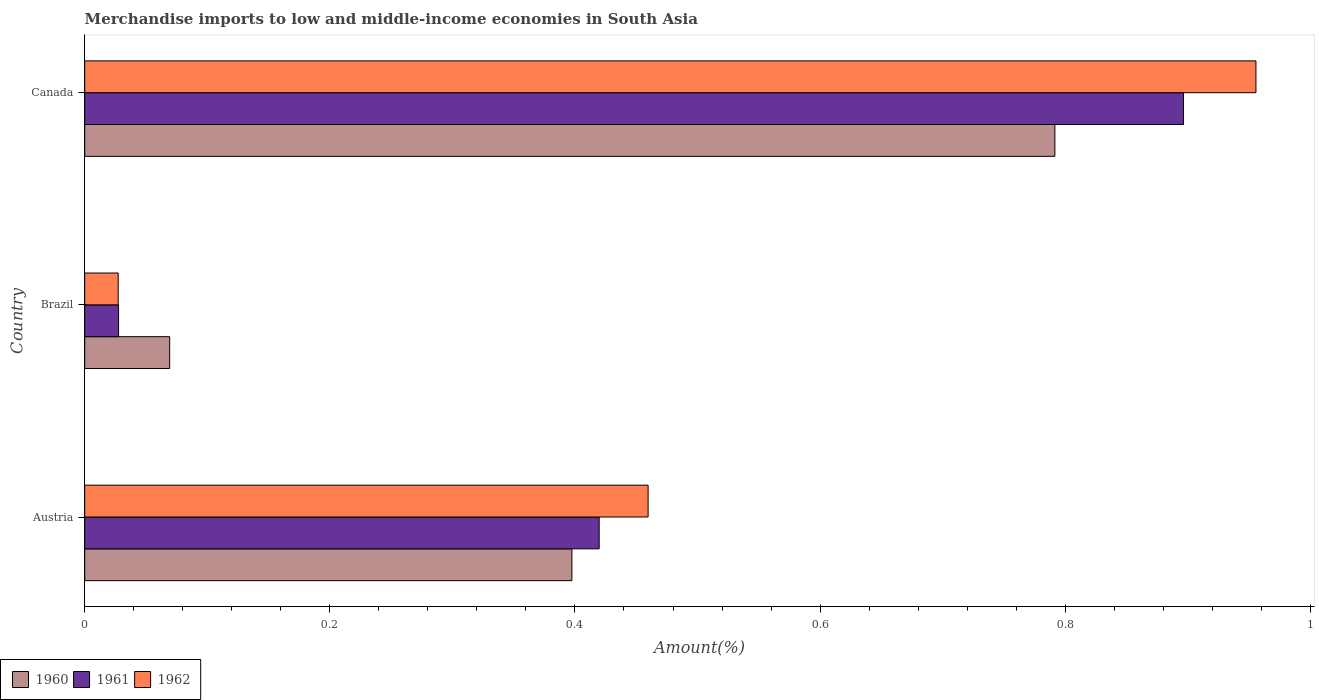How many groups of bars are there?
Give a very brief answer. 3. Are the number of bars on each tick of the Y-axis equal?
Give a very brief answer. Yes. How many bars are there on the 3rd tick from the top?
Your response must be concise. 3. What is the label of the 1st group of bars from the top?
Provide a succinct answer. Canada. What is the percentage of amount earned from merchandise imports in 1961 in Canada?
Your answer should be very brief. 0.9. Across all countries, what is the maximum percentage of amount earned from merchandise imports in 1961?
Make the answer very short. 0.9. Across all countries, what is the minimum percentage of amount earned from merchandise imports in 1962?
Make the answer very short. 0.03. In which country was the percentage of amount earned from merchandise imports in 1960 minimum?
Make the answer very short. Brazil. What is the total percentage of amount earned from merchandise imports in 1961 in the graph?
Your answer should be compact. 1.34. What is the difference between the percentage of amount earned from merchandise imports in 1962 in Austria and that in Brazil?
Your response must be concise. 0.43. What is the difference between the percentage of amount earned from merchandise imports in 1960 in Canada and the percentage of amount earned from merchandise imports in 1962 in Brazil?
Your answer should be compact. 0.76. What is the average percentage of amount earned from merchandise imports in 1962 per country?
Offer a terse response. 0.48. What is the difference between the percentage of amount earned from merchandise imports in 1960 and percentage of amount earned from merchandise imports in 1962 in Canada?
Your answer should be very brief. -0.16. In how many countries, is the percentage of amount earned from merchandise imports in 1960 greater than 0.32 %?
Give a very brief answer. 2. What is the ratio of the percentage of amount earned from merchandise imports in 1960 in Brazil to that in Canada?
Your answer should be very brief. 0.09. Is the percentage of amount earned from merchandise imports in 1961 in Austria less than that in Canada?
Provide a short and direct response. Yes. What is the difference between the highest and the second highest percentage of amount earned from merchandise imports in 1960?
Your answer should be very brief. 0.39. What is the difference between the highest and the lowest percentage of amount earned from merchandise imports in 1960?
Provide a succinct answer. 0.72. What does the 1st bar from the bottom in Brazil represents?
Provide a succinct answer. 1960. What is the difference between two consecutive major ticks on the X-axis?
Give a very brief answer. 0.2. Does the graph contain grids?
Keep it short and to the point. No. Where does the legend appear in the graph?
Provide a short and direct response. Bottom left. How many legend labels are there?
Provide a succinct answer. 3. How are the legend labels stacked?
Ensure brevity in your answer.  Horizontal. What is the title of the graph?
Keep it short and to the point. Merchandise imports to low and middle-income economies in South Asia. What is the label or title of the X-axis?
Your answer should be very brief. Amount(%). What is the Amount(%) in 1960 in Austria?
Your answer should be very brief. 0.4. What is the Amount(%) of 1961 in Austria?
Provide a short and direct response. 0.42. What is the Amount(%) in 1962 in Austria?
Offer a very short reply. 0.46. What is the Amount(%) in 1960 in Brazil?
Offer a very short reply. 0.07. What is the Amount(%) in 1961 in Brazil?
Provide a succinct answer. 0.03. What is the Amount(%) in 1962 in Brazil?
Offer a very short reply. 0.03. What is the Amount(%) of 1960 in Canada?
Keep it short and to the point. 0.79. What is the Amount(%) in 1961 in Canada?
Keep it short and to the point. 0.9. What is the Amount(%) in 1962 in Canada?
Your response must be concise. 0.96. Across all countries, what is the maximum Amount(%) of 1960?
Your answer should be very brief. 0.79. Across all countries, what is the maximum Amount(%) of 1961?
Provide a short and direct response. 0.9. Across all countries, what is the maximum Amount(%) in 1962?
Provide a succinct answer. 0.96. Across all countries, what is the minimum Amount(%) in 1960?
Your answer should be compact. 0.07. Across all countries, what is the minimum Amount(%) in 1961?
Provide a short and direct response. 0.03. Across all countries, what is the minimum Amount(%) in 1962?
Offer a terse response. 0.03. What is the total Amount(%) of 1960 in the graph?
Offer a very short reply. 1.26. What is the total Amount(%) in 1961 in the graph?
Your answer should be very brief. 1.34. What is the total Amount(%) of 1962 in the graph?
Your answer should be very brief. 1.44. What is the difference between the Amount(%) in 1960 in Austria and that in Brazil?
Give a very brief answer. 0.33. What is the difference between the Amount(%) of 1961 in Austria and that in Brazil?
Provide a succinct answer. 0.39. What is the difference between the Amount(%) in 1962 in Austria and that in Brazil?
Offer a very short reply. 0.43. What is the difference between the Amount(%) of 1960 in Austria and that in Canada?
Provide a short and direct response. -0.39. What is the difference between the Amount(%) in 1961 in Austria and that in Canada?
Provide a short and direct response. -0.48. What is the difference between the Amount(%) in 1962 in Austria and that in Canada?
Keep it short and to the point. -0.5. What is the difference between the Amount(%) in 1960 in Brazil and that in Canada?
Ensure brevity in your answer.  -0.72. What is the difference between the Amount(%) in 1961 in Brazil and that in Canada?
Provide a short and direct response. -0.87. What is the difference between the Amount(%) in 1962 in Brazil and that in Canada?
Your answer should be compact. -0.93. What is the difference between the Amount(%) of 1960 in Austria and the Amount(%) of 1961 in Brazil?
Provide a succinct answer. 0.37. What is the difference between the Amount(%) of 1960 in Austria and the Amount(%) of 1962 in Brazil?
Offer a terse response. 0.37. What is the difference between the Amount(%) in 1961 in Austria and the Amount(%) in 1962 in Brazil?
Give a very brief answer. 0.39. What is the difference between the Amount(%) in 1960 in Austria and the Amount(%) in 1961 in Canada?
Keep it short and to the point. -0.5. What is the difference between the Amount(%) of 1960 in Austria and the Amount(%) of 1962 in Canada?
Provide a short and direct response. -0.56. What is the difference between the Amount(%) of 1961 in Austria and the Amount(%) of 1962 in Canada?
Offer a very short reply. -0.54. What is the difference between the Amount(%) of 1960 in Brazil and the Amount(%) of 1961 in Canada?
Your answer should be very brief. -0.83. What is the difference between the Amount(%) of 1960 in Brazil and the Amount(%) of 1962 in Canada?
Keep it short and to the point. -0.89. What is the difference between the Amount(%) of 1961 in Brazil and the Amount(%) of 1962 in Canada?
Your answer should be very brief. -0.93. What is the average Amount(%) in 1960 per country?
Provide a succinct answer. 0.42. What is the average Amount(%) in 1961 per country?
Give a very brief answer. 0.45. What is the average Amount(%) in 1962 per country?
Provide a short and direct response. 0.48. What is the difference between the Amount(%) in 1960 and Amount(%) in 1961 in Austria?
Provide a short and direct response. -0.02. What is the difference between the Amount(%) of 1960 and Amount(%) of 1962 in Austria?
Your answer should be very brief. -0.06. What is the difference between the Amount(%) in 1961 and Amount(%) in 1962 in Austria?
Provide a short and direct response. -0.04. What is the difference between the Amount(%) in 1960 and Amount(%) in 1961 in Brazil?
Your answer should be very brief. 0.04. What is the difference between the Amount(%) in 1960 and Amount(%) in 1962 in Brazil?
Ensure brevity in your answer.  0.04. What is the difference between the Amount(%) of 1960 and Amount(%) of 1961 in Canada?
Offer a terse response. -0.1. What is the difference between the Amount(%) in 1960 and Amount(%) in 1962 in Canada?
Offer a very short reply. -0.16. What is the difference between the Amount(%) of 1961 and Amount(%) of 1962 in Canada?
Ensure brevity in your answer.  -0.06. What is the ratio of the Amount(%) in 1960 in Austria to that in Brazil?
Your answer should be compact. 5.73. What is the ratio of the Amount(%) in 1961 in Austria to that in Brazil?
Offer a very short reply. 15.2. What is the ratio of the Amount(%) of 1962 in Austria to that in Brazil?
Offer a terse response. 16.83. What is the ratio of the Amount(%) of 1960 in Austria to that in Canada?
Provide a short and direct response. 0.5. What is the ratio of the Amount(%) in 1961 in Austria to that in Canada?
Provide a short and direct response. 0.47. What is the ratio of the Amount(%) in 1962 in Austria to that in Canada?
Provide a short and direct response. 0.48. What is the ratio of the Amount(%) of 1960 in Brazil to that in Canada?
Ensure brevity in your answer.  0.09. What is the ratio of the Amount(%) in 1961 in Brazil to that in Canada?
Offer a terse response. 0.03. What is the ratio of the Amount(%) of 1962 in Brazil to that in Canada?
Make the answer very short. 0.03. What is the difference between the highest and the second highest Amount(%) of 1960?
Offer a terse response. 0.39. What is the difference between the highest and the second highest Amount(%) in 1961?
Provide a succinct answer. 0.48. What is the difference between the highest and the second highest Amount(%) in 1962?
Offer a terse response. 0.5. What is the difference between the highest and the lowest Amount(%) of 1960?
Ensure brevity in your answer.  0.72. What is the difference between the highest and the lowest Amount(%) of 1961?
Ensure brevity in your answer.  0.87. What is the difference between the highest and the lowest Amount(%) of 1962?
Your response must be concise. 0.93. 